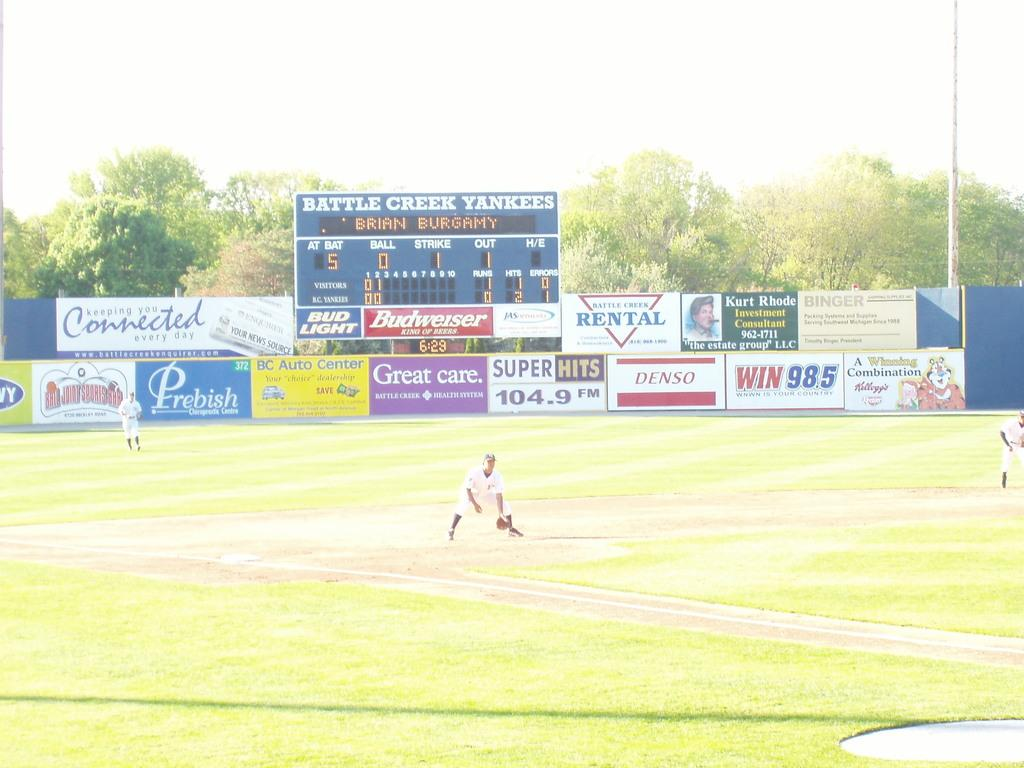<image>
Provide a brief description of the given image. The outfield fence of the Battle Creek Yankees' stadium features advertisements from many companies, including Budweiser and Denso. 